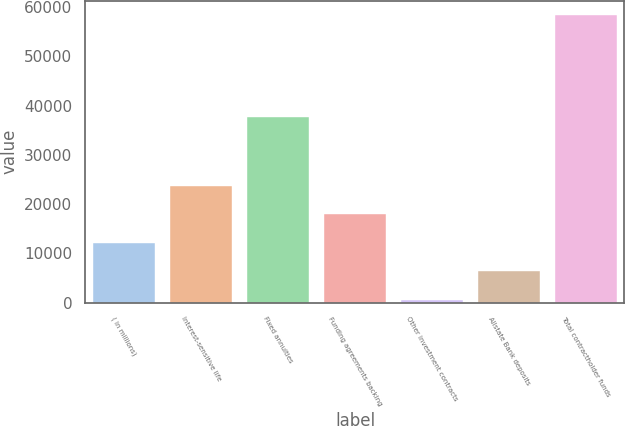Convert chart to OTSL. <chart><loc_0><loc_0><loc_500><loc_500><bar_chart><fcel>( in millions)<fcel>Interest-sensitive life<fcel>Fixed annuities<fcel>Funding agreements backing<fcel>Other investment contracts<fcel>Allstate Bank deposits<fcel>Total contractholder funds<nl><fcel>12109<fcel>23685<fcel>37660<fcel>17897<fcel>533<fcel>6321<fcel>58413<nl></chart> 